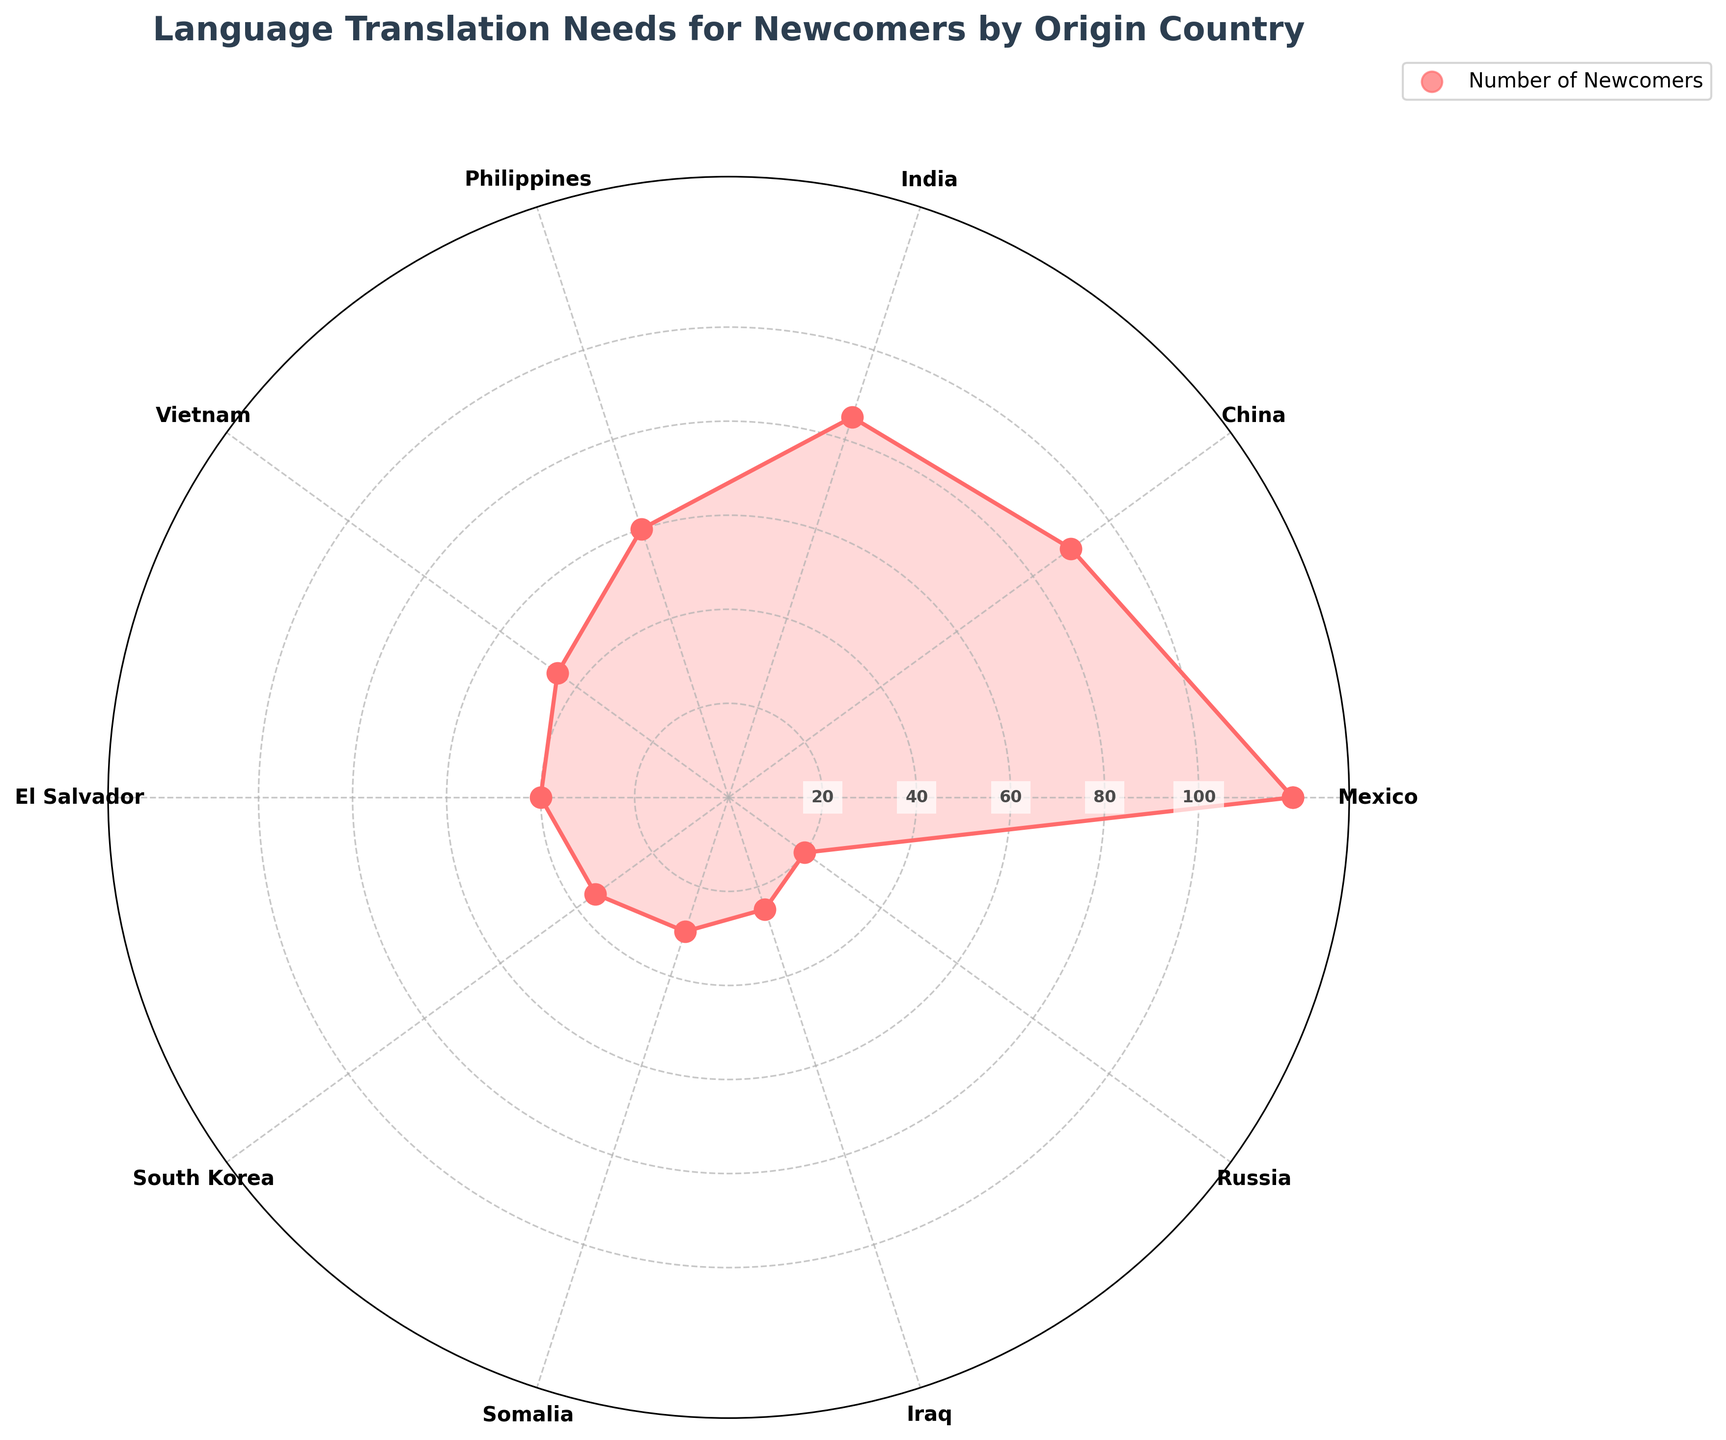What's the title of the figure? The title of the figure is displayed prominently at the top of the figure.
Answer: Language Translation Needs for Newcomers by Origin Country Which country has the highest number of newcomers? By looking at the longest segment from the center in the polar area chart, we can see that Mexico has the longest segment.
Answer: Mexico What languages are needed for translation other than Spanish? From the polar area chart, we can see the labels for each country, and by referring to the table which lists languages, we can enumerate all languages except Spanish: Mandarin, Hindi, Tagalog, Vietnamese, Korean, Somali, Arabic, Russian.
Answer: Mandarin, Hindi, Tagalog, Vietnamese, Korean, Somali, Arabic, Russian How many countries have newcomers needing Spanish translation? Identifying segments associated with Spanish translation in the chart and cross-referencing with the data table, we see Mexico and El Salvador.
Answer: 2 What translation need is associated with the smallest number of newcomers? By identifying the smallest segment from the center, which represents 20 newcomers from Russia, we look at the associated translation need.
Answer: Russian Add the total number of newcomers needing translation from the Philippines and Vietnam. According to the chart, the Philippines has 60 newcomers and Vietnam has 45 newcomers. Adding these numbers gives us 60 + 45.
Answer: 105 Compare the number of newcomers from India and South Korea. Which is greater, and by how much? India has 85 newcomers, and South Korea has 35 newcomers. By subtracting these we find that India has 85 - 35 more newcomers.
Answer: India has 50 more newcomers What is the average number of newcomers from the top 3 countries? The top 3 countries by newcomer count are Mexico (120), China (90), and India (85). The sum of these values is 120 + 90 + 85 = 295. Dividing by 3 gives an average of 98.33.
Answer: 98.33 How does the number of newcomers from China compare with the total number from Somalia and Iraq combined? China has 90 newcomers. Somalia and Iraq have 30 and 25 newcomers respectively, summing to 30 + 25 = 55. Comparing these values, China has 90 - 55 more newcomers.
Answer: China has 35 more What's the sum of newcomers from countries needing Tagalog and Arabic translations? According to the chart, the Philippines has 60 (Tagalog), and Iraq has 25 (Arabic). Summing these gives 60 + 25.
Answer: 85 